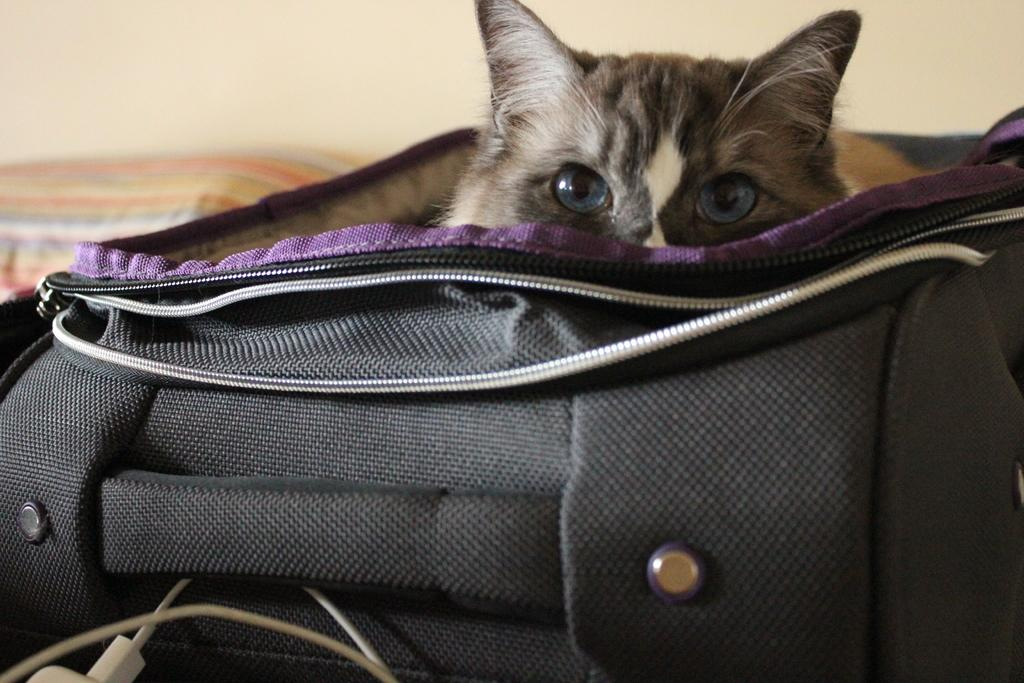What type of animal is in the image? There is a cat in the image. Where is the cat located? The cat is inside a luggage bag. What can be seen in the front of the image? There is a white cable in the front of the image. What is visible in the background of the image? There is a wall in the background of the image. What type of jelly is being discussed in the image? There is no discussion of jelly in the image, as it features a cat inside a luggage bag and a white cable in the front. What is the cat's reaction to the surprise in the image? There is no surprise present in the image, as it only features a cat, a luggage bag, a white cable, and a wall in the background. 